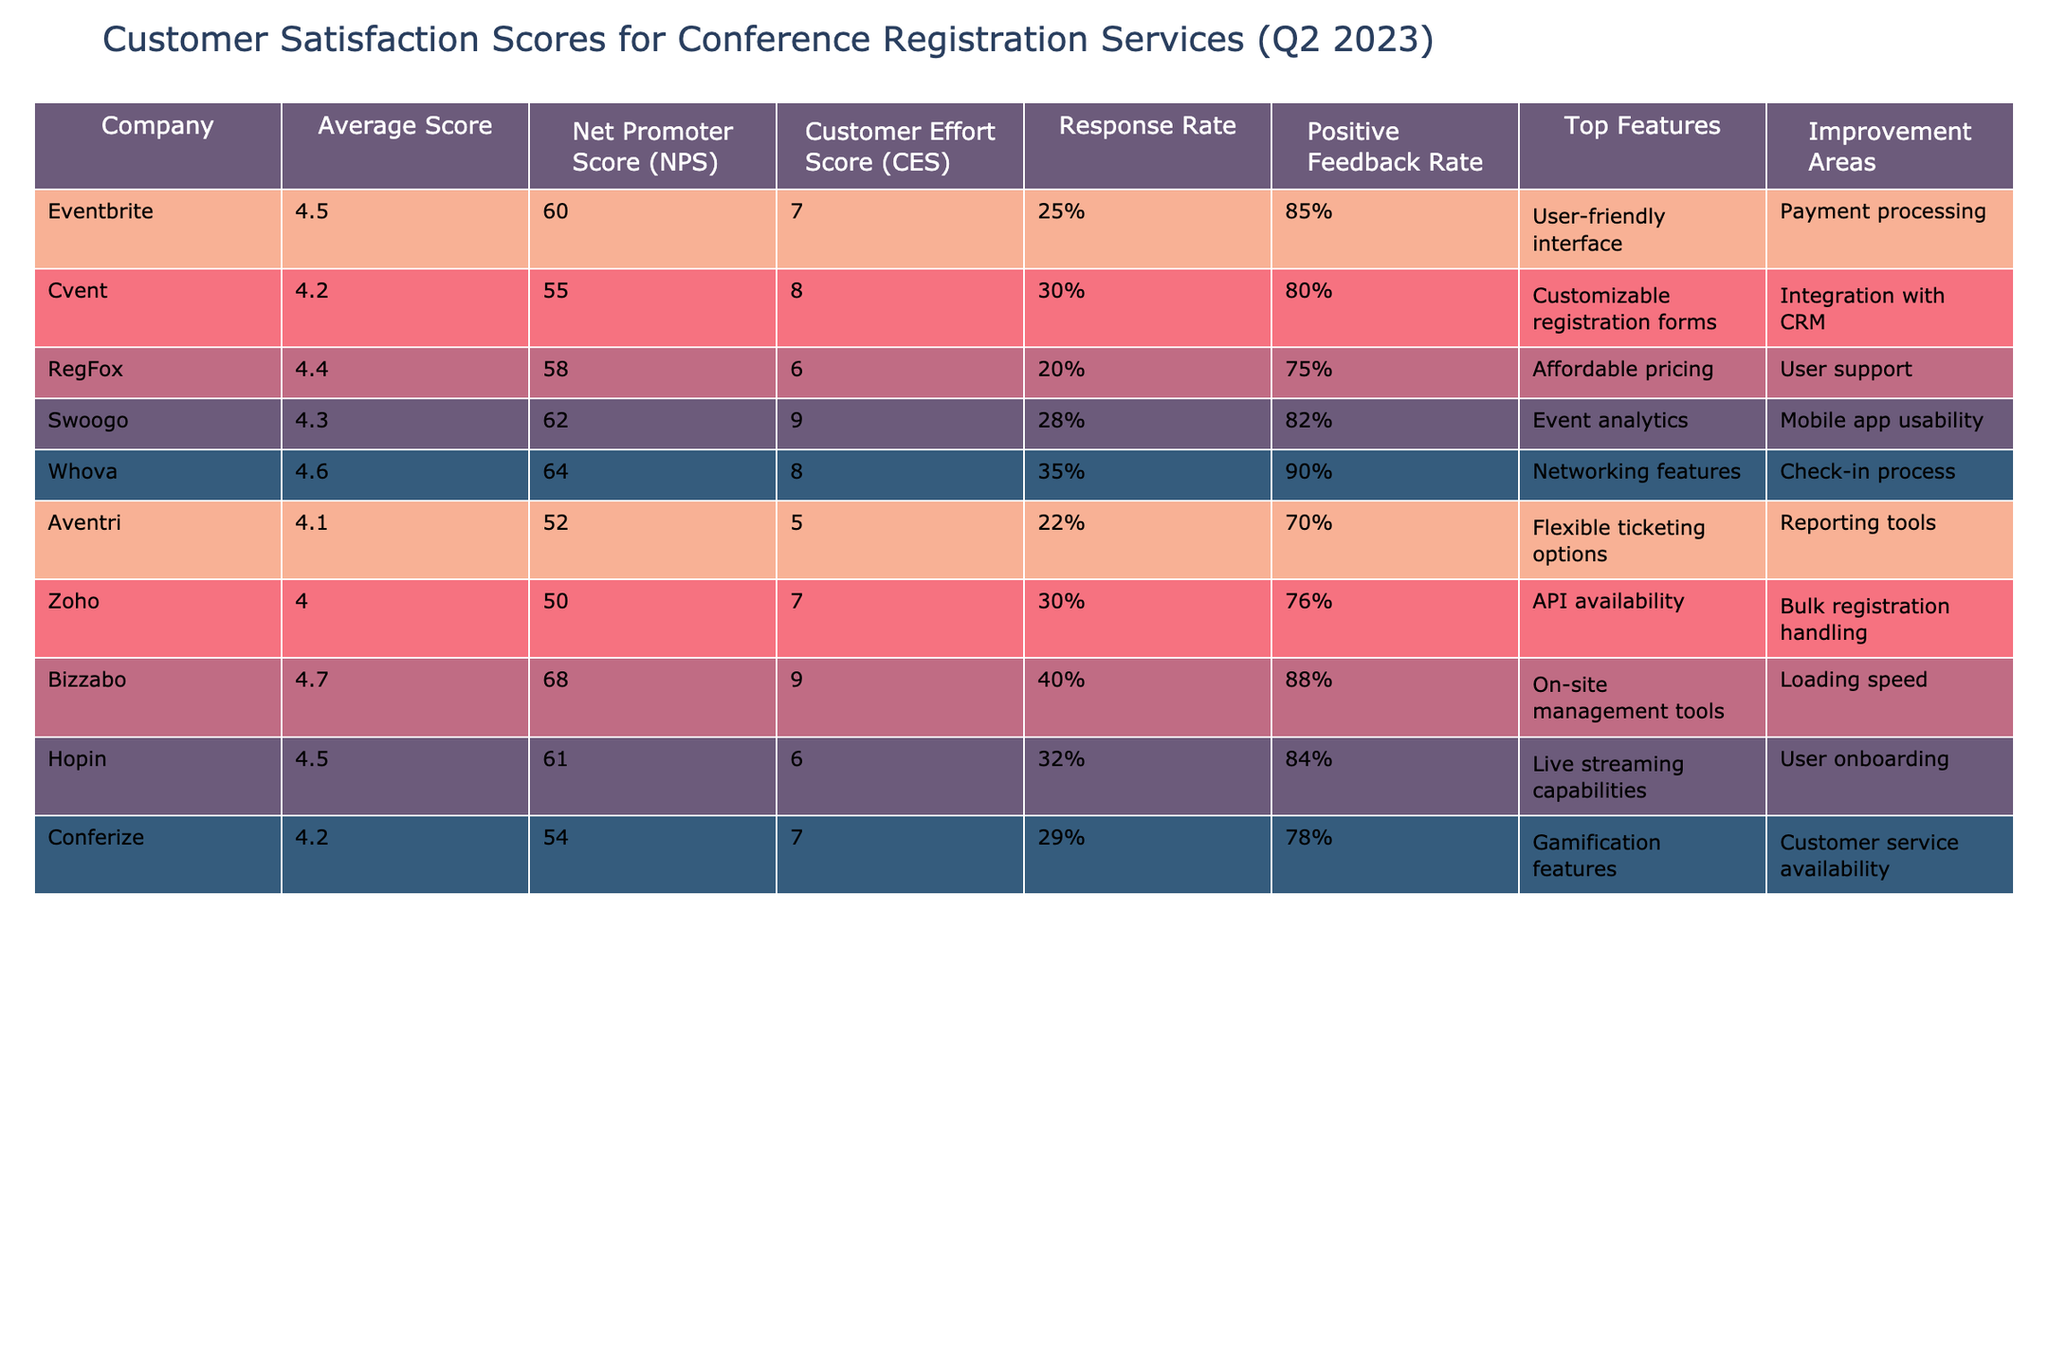What is the company with the highest average score? By inspecting the Average Score column, we can see that Bizzabo has the highest score at 4.7.
Answer: Bizzabo What is the Net Promoter Score (NPS) of Whova? The Net Promoter Score of Whova can be found in the respective column, which shows that it is 64.
Answer: 64 Which company has the lowest Customer Effort Score (CES)? Looking at the CES column, Aventri shows the lowest score at 5.
Answer: Aventri What is the average Net Promoter Score (NPS) of the listed companies? To find the average NPS, sum the NPS of all companies: (60 + 55 + 58 + 62 + 64 + 52 + 50 + 68 + 61 + 54) =  585. Then, divide by the number of companies (10): 585/10 = 58.5.
Answer: 58.5 Is the Positive Feedback Rate of RegFox higher than that of Zoho? Checking the Positive Feedback Rates, RegFox has a rate of 75% and Zoho has 76%. Since 75% is less than 76%, the statement is false.
Answer: No Which company has the best response rate and what is the score? The response rate can be evaluated by identifying the highest value in the Response Rate column, which shows Bizzabo has the highest at 40%.
Answer: Bizzabo, 40% If we consider the Top Features of the company with the highest score, what is it? First, we identify that Bizzabo has the highest average score at 4.7, then look at the Top Features column for Bizzabo, which lists On-site management tools.
Answer: On-site management tools How many companies have an Average Score greater than 4.4? Review the Average Score column to count companies with scores exceeding 4.4: Eventbrite (4.5), Bizzabo (4.7), and Whova (4.6). There are 3 such companies.
Answer: 3 Which company has the most positive feedback and what is the percentage? The Positive Feedback Rate shows that Whova has the highest at 90%.
Answer: Whova, 90% Is there a company with an Average Score of 4.0? By checking the Average Score column, we see that Zoho has an average score exactly equal to 4.0, so the answer is yes.
Answer: Yes 